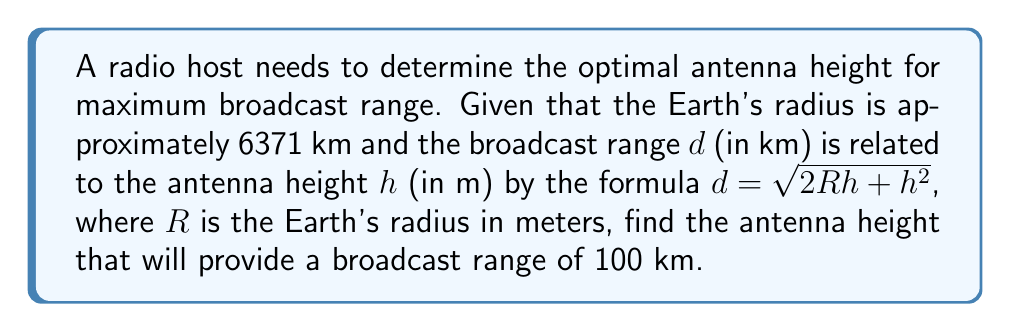Can you answer this question? 1) First, we need to convert the Earth's radius to meters:
   $R = 6371 \text{ km} = 6,371,000 \text{ m}$

2) We're given the formula: $d = \sqrt{2Rh + h^2}$

3) We know $d = 100 \text{ km} = 100,000 \text{ m}$, so we can substitute this into the equation:
   $100,000 = \sqrt{2Rh + h^2}$

4) Square both sides:
   $10,000,000,000 = 2Rh + h^2$

5) Substitute the value of $R$:
   $10,000,000,000 = 2(6,371,000)h + h^2$

6) Simplify:
   $10,000,000,000 = 12,742,000h + h^2$

7) Rearrange into standard quadratic form:
   $h^2 + 12,742,000h - 10,000,000,000 = 0$

8) This is a quadratic equation in the form $ah^2 + bh + c = 0$, where:
   $a = 1$
   $b = 12,742,000$
   $c = -10,000,000,000$

9) We can solve this using the quadratic formula: $h = \frac{-b \pm \sqrt{b^2 - 4ac}}{2a}$

10) Substituting our values:
    $h = \frac{-12,742,000 \pm \sqrt{12,742,000^2 - 4(1)(-10,000,000,000)}}{2(1)}$

11) Simplify:
    $h = \frac{-12,742,000 \pm \sqrt{162,358,564,000,000 + 40,000,000,000}}{2}$
    $h = \frac{-12,742,000 \pm \sqrt{162,398,564,000,000}}{2}$
    $h = \frac{-12,742,000 \pm 12,743,953.8}{2}$

12) This gives us two solutions:
    $h = \frac{-12,742,000 + 12,743,953.8}{2} = 976.9 \text{ m}$
    $h = \frac{-12,742,000 - 12,743,953.8}{2} = -12,742,976.9 \text{ m}$

13) Since height cannot be negative, we discard the negative solution.
Answer: 976.9 m 